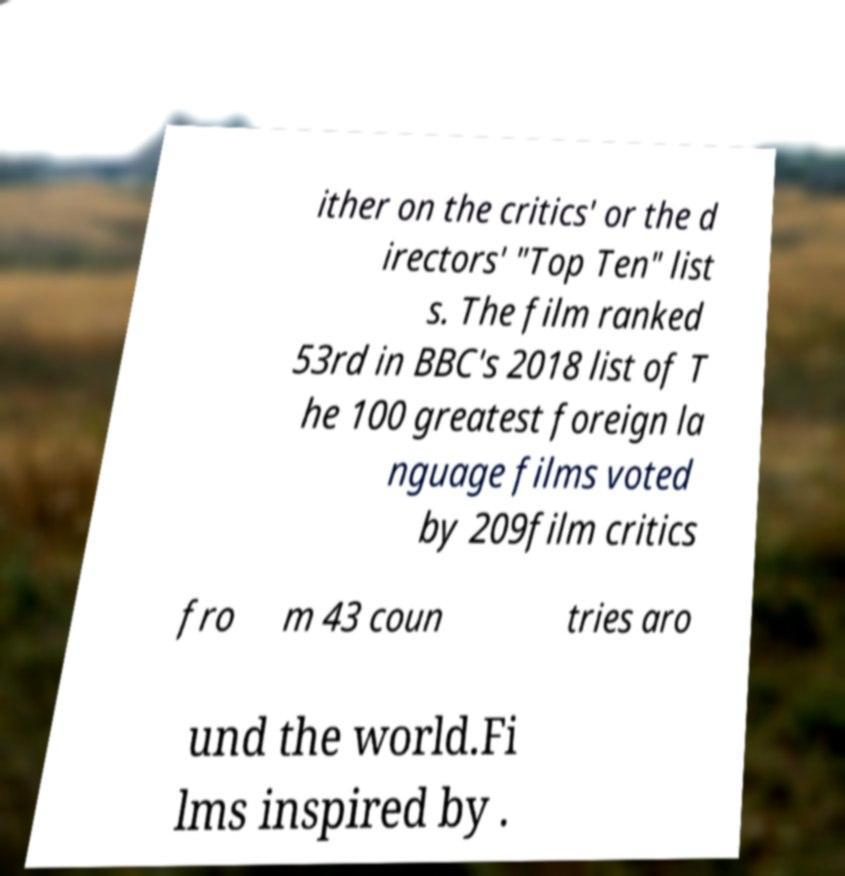For documentation purposes, I need the text within this image transcribed. Could you provide that? ither on the critics' or the d irectors' "Top Ten" list s. The film ranked 53rd in BBC's 2018 list of T he 100 greatest foreign la nguage films voted by 209film critics fro m 43 coun tries aro und the world.Fi lms inspired by . 